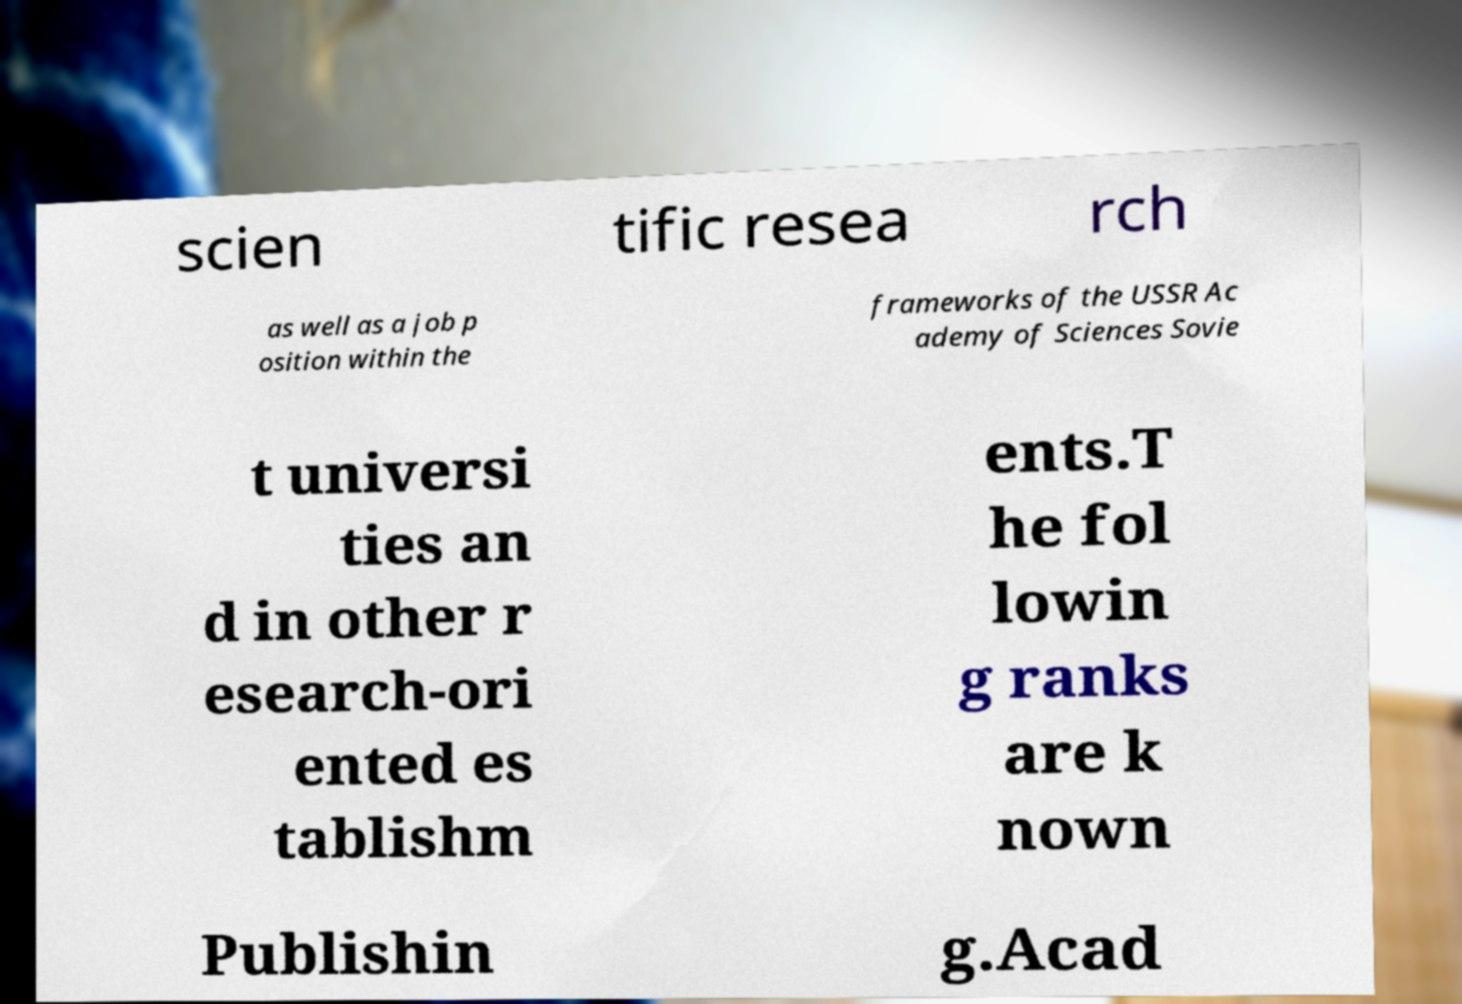There's text embedded in this image that I need extracted. Can you transcribe it verbatim? scien tific resea rch as well as a job p osition within the frameworks of the USSR Ac ademy of Sciences Sovie t universi ties an d in other r esearch-ori ented es tablishm ents.T he fol lowin g ranks are k nown Publishin g.Acad 